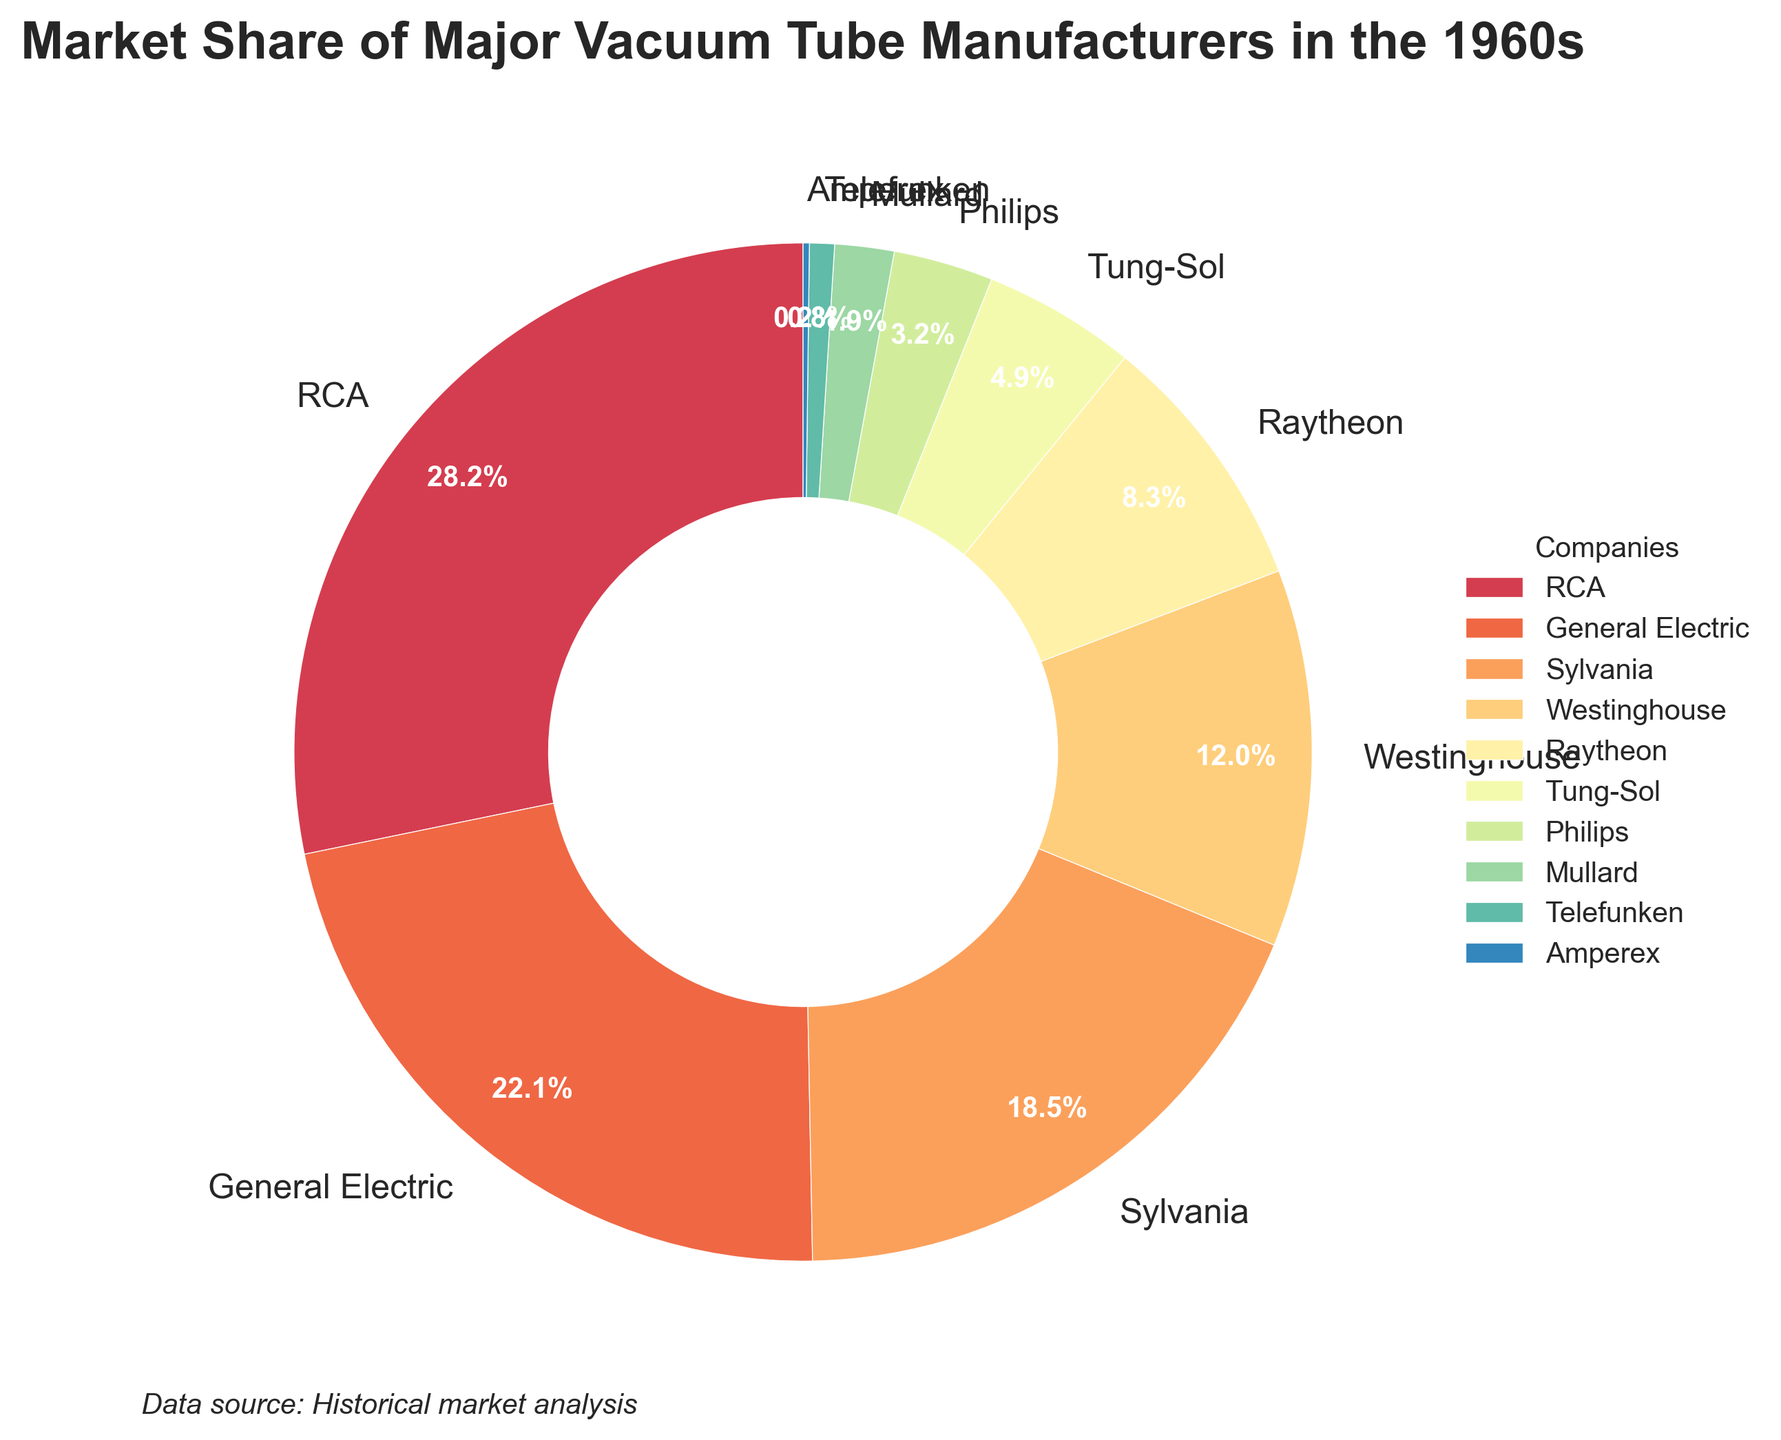What percentage of the market share did RCA have in the 1960s? The pie chart shows that RCA had the largest wedge, with a label indicating 28.5%.
Answer: 28.5% Which two companies combined have the largest market share, and what is their combined percentage? RCA has a market share of 28.5% and General Electric has a market share of 22.3%. Adding these together yields 28.5% + 22.3% = 50.8%.
Answer: RCA and General Electric, 50.8% Which company has the smallest market share, and what percentage is it? The smallest wedge is labeled Amperex, with a share of 0.2%.
Answer: Amperex, 0.2% What is the total market share of Sylvania, Westinghouse, and Raytheon? Adding their respective market shares: 18.7% (Sylvania) + 12.1% (Westinghouse) + 8.4% (Raytheon) = 39.2%.
Answer: 39.2% How does the market share of Tung-Sol compare to that of Philips? Tung-Sol has a market share of 4.9%, while Philips has 3.2%. 4.9% is greater than 3.2%.
Answer: Tung-Sol has a higher market share than Philips Which companies have a market share less than 5%? The pie chart shows Tung-Sol (4.9%), Philips (3.2%), Mullard (1.9%), Telefunken (0.8%), and Amperex (0.2%) each having less than 5%.
Answer: Tung-Sol, Philips, Mullard, Telefunken, Amperex If you combine the market shares of Telefunken and Amperex, do they exceed 1%? Adding the market shares of Telefunken (0.8%) and Amperex (0.2%) results in 0.8% + 0.2% = 1.0%, exactly 1%.
Answer: No, they exactly total 1% What's the difference in market share between Sylvania and Westinghouse? Subtracting the market share of Westinghouse from Sylvania's: 18.7% - 12.1% = 6.6%.
Answer: 6.6% Which company has the second-largest market share, and what is the percentage? The pie chart shows General Electric as the company with the second-largest market share, labeled 22.3%.
Answer: General Electric, 22.3% 